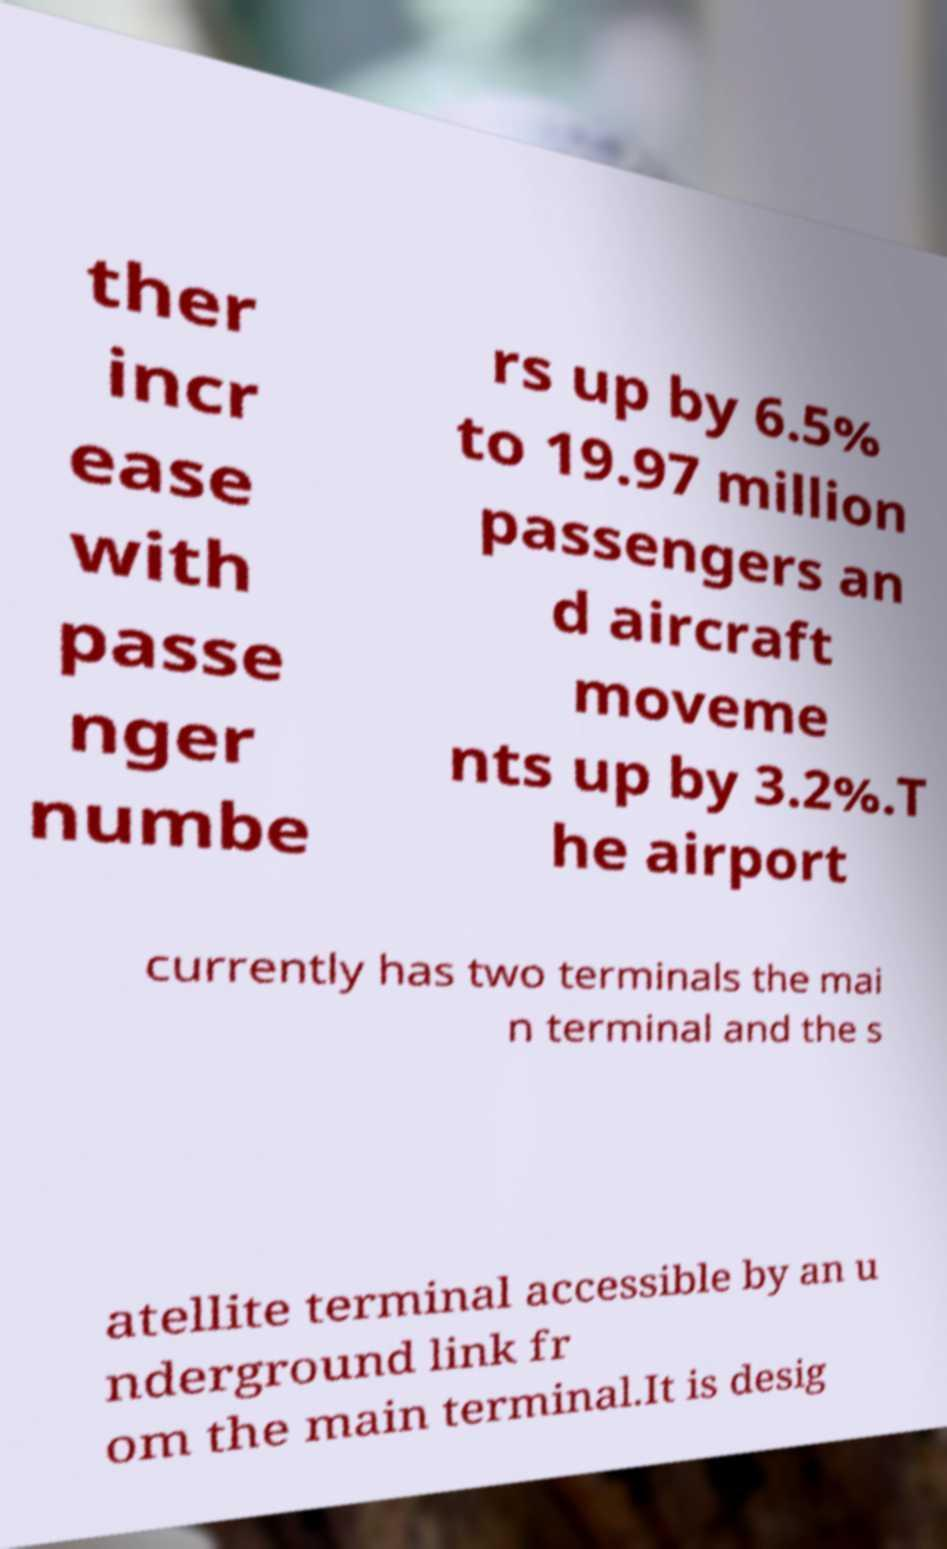Please read and relay the text visible in this image. What does it say? ther incr ease with passe nger numbe rs up by 6.5% to 19.97 million passengers an d aircraft moveme nts up by 3.2%.T he airport currently has two terminals the mai n terminal and the s atellite terminal accessible by an u nderground link fr om the main terminal.It is desig 